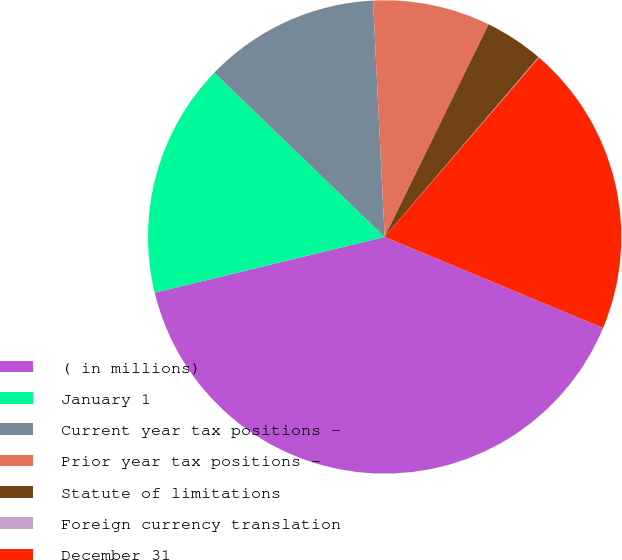Convert chart. <chart><loc_0><loc_0><loc_500><loc_500><pie_chart><fcel>( in millions)<fcel>January 1<fcel>Current year tax positions -<fcel>Prior year tax positions -<fcel>Statute of limitations<fcel>Foreign currency translation<fcel>December 31<nl><fcel>39.93%<fcel>16.0%<fcel>12.01%<fcel>8.02%<fcel>4.03%<fcel>0.04%<fcel>19.98%<nl></chart> 